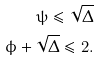Convert formula to latex. <formula><loc_0><loc_0><loc_500><loc_500>\psi \leq \sqrt { \Delta } \\ \phi + \sqrt { \Delta } \leq 2 .</formula> 